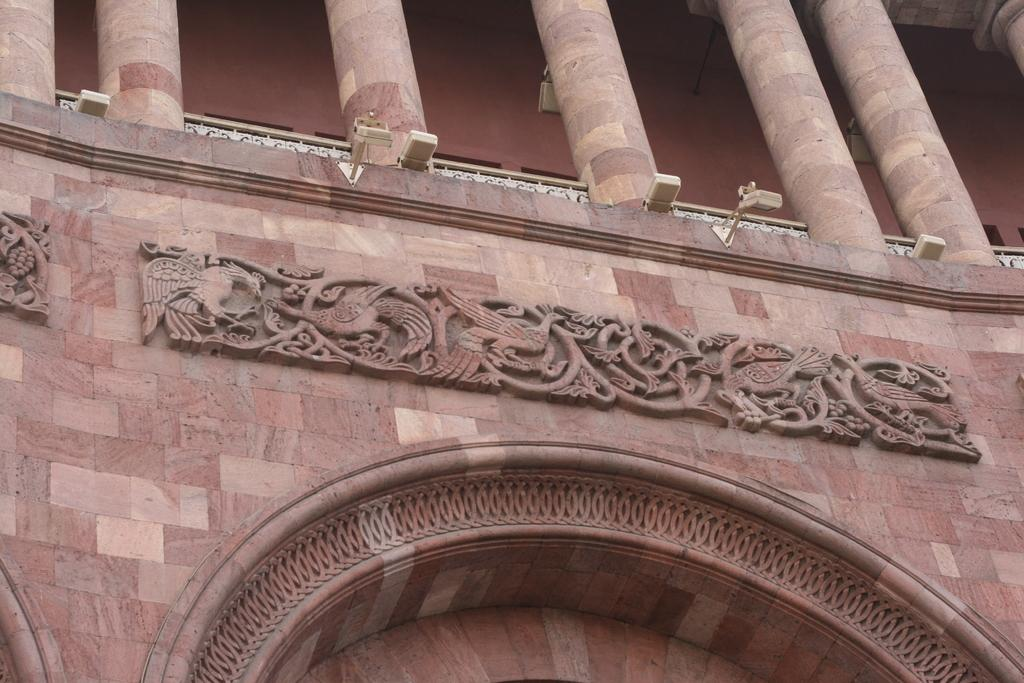What type of structure is present in the image? There is a building in the image. What architectural feature can be seen on the building? The building has stone pillars. What can be seen illuminating the building or its surroundings? There are lights visible in the image. What type of bead is being used to wash the stone pillars in the image? There is no bead or washing activity present in the image; it only shows a building with stone pillars and lights. 